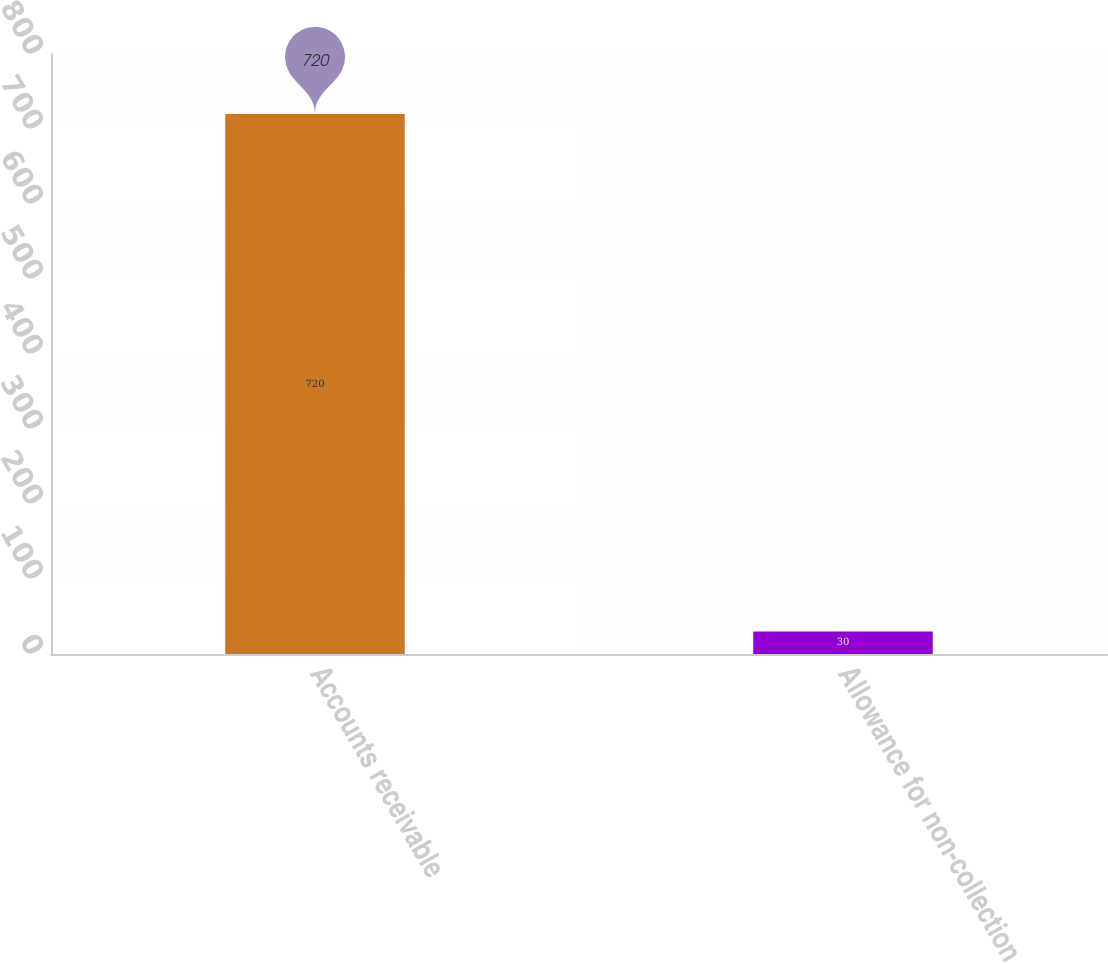<chart> <loc_0><loc_0><loc_500><loc_500><bar_chart><fcel>Accounts receivable<fcel>Allowance for non-collection<nl><fcel>720<fcel>30<nl></chart> 